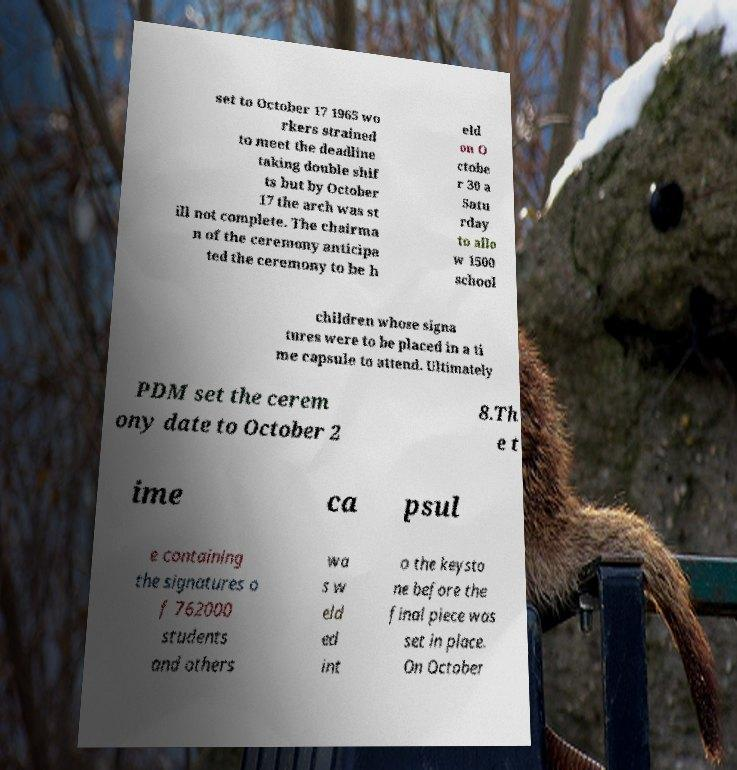Please identify and transcribe the text found in this image. set to October 17 1965 wo rkers strained to meet the deadline taking double shif ts but by October 17 the arch was st ill not complete. The chairma n of the ceremony anticipa ted the ceremony to be h eld on O ctobe r 30 a Satu rday to allo w 1500 school children whose signa tures were to be placed in a ti me capsule to attend. Ultimately PDM set the cerem ony date to October 2 8.Th e t ime ca psul e containing the signatures o f 762000 students and others wa s w eld ed int o the keysto ne before the final piece was set in place. On October 